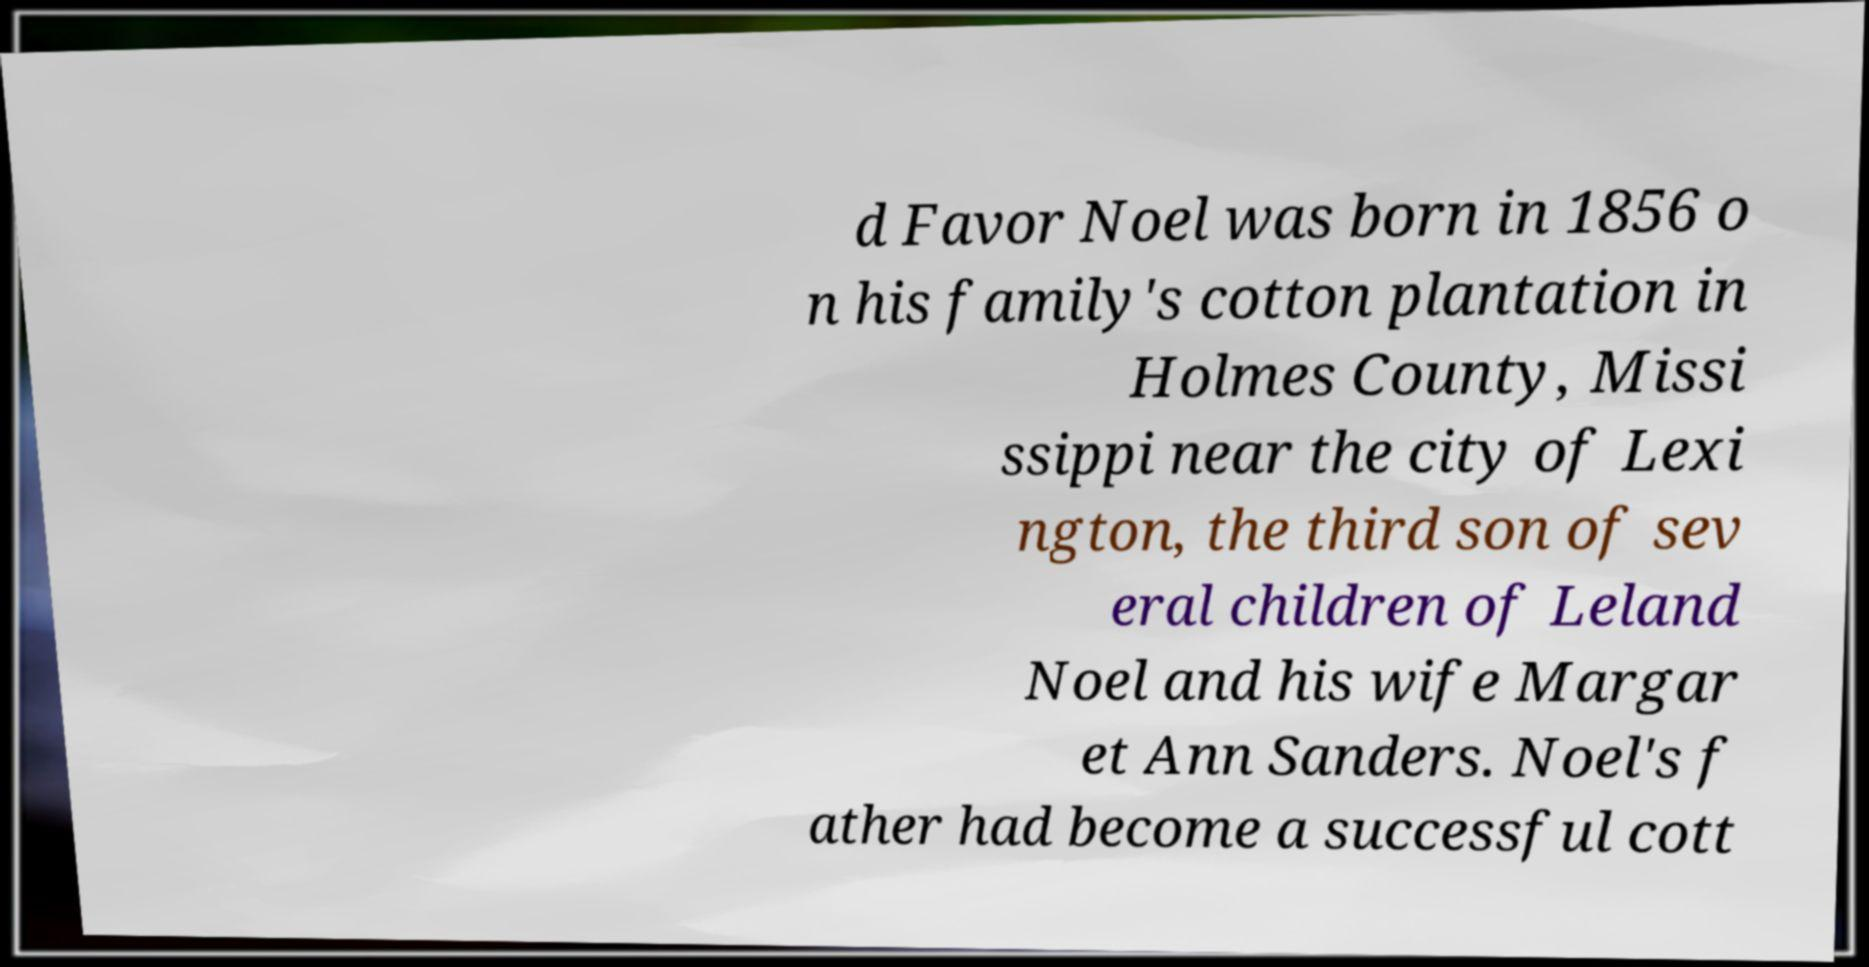Can you accurately transcribe the text from the provided image for me? d Favor Noel was born in 1856 o n his family's cotton plantation in Holmes County, Missi ssippi near the city of Lexi ngton, the third son of sev eral children of Leland Noel and his wife Margar et Ann Sanders. Noel's f ather had become a successful cott 